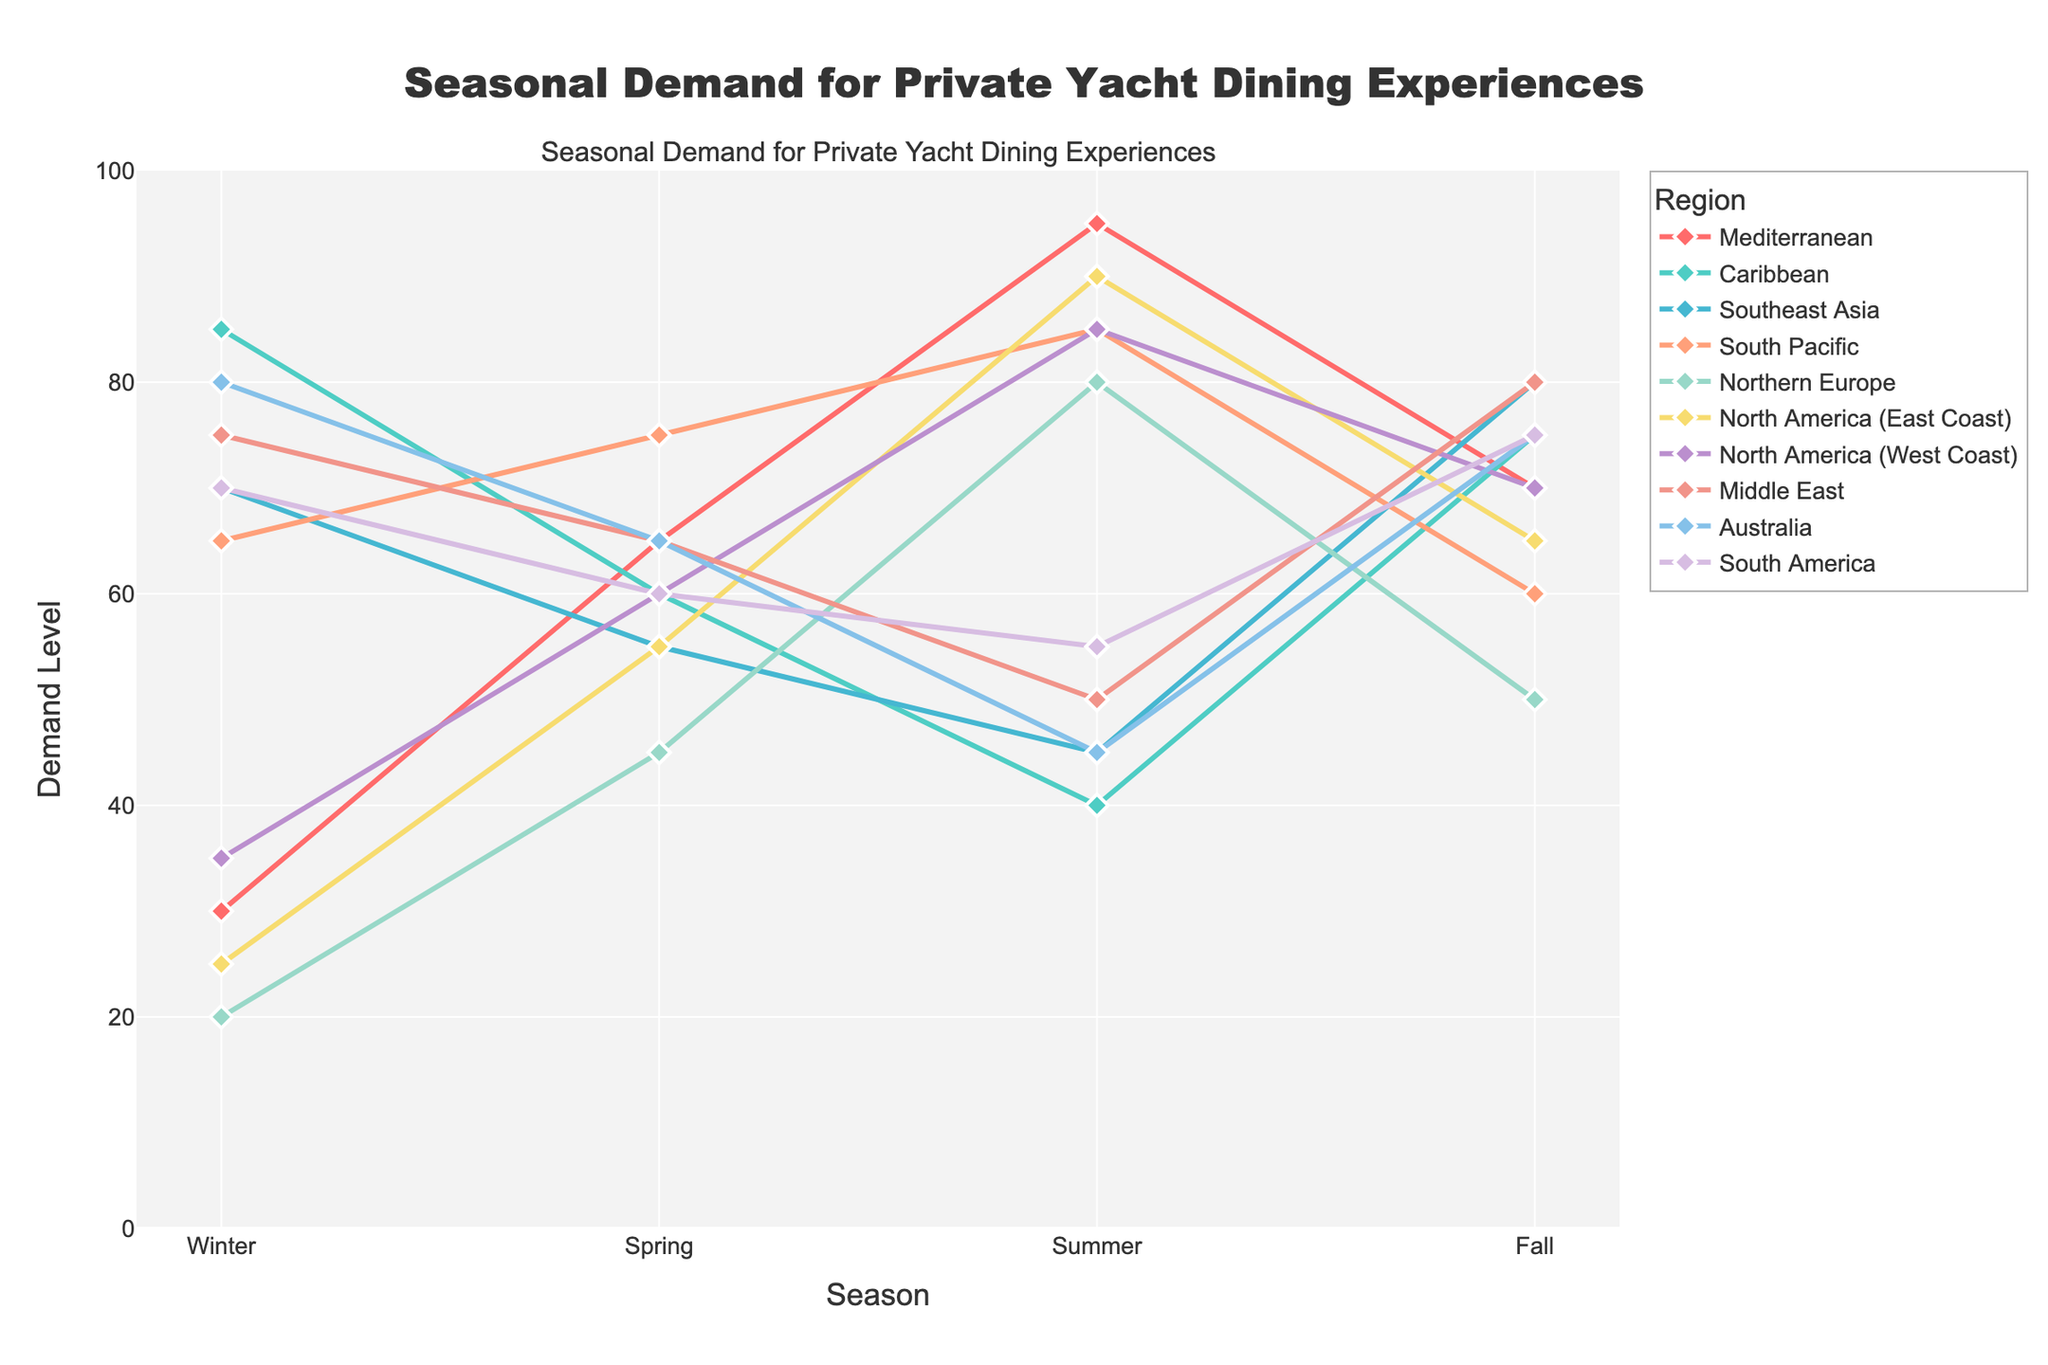What is the demand level for private yacht dining experiences in the Mediterranean during Summer? Look at the Mediterranean region line on the chart and find its corresponding value during the Summer season.
Answer: 95 During which season does the Caribbean region have the highest demand? Examine the line representing the Caribbean region and identify the peak point across the seasons.
Answer: Winter Which region has the highest demand in Fall? Observe the demand levels in Fall for all regions and identify the one with the highest value.
Answer: Middle East What is the average demand across all regions in Winter? Sum the demand levels for each region in Winter and divide by the number of regions (30 + 85 + 70 + 65 + 20 + 25 + 35 + 75 + 80 + 70) / 10.
Answer: 55.5 In which season does Southeast Asia have the lowest demand? Look at the line for Southeast Asia and find the lowest data point.
Answer: Summer Which region experiences the most significant increase in demand from Winter to Summer? Calculate the difference between Summer and Winter demand for each region and find the one with the largest increase (Mediterranean: 65, Caribbean: -45, Southeast Asia: -25, South Pacific: 20, Northern Europe: 60, North America (East Coast): 65, North America (West Coast): 50, Middle East: -25, Australia: -35, South America: -15).
Answer: Mediterranean How does the demand in Northern Europe during Fall compare to that in Spring? Compare the demand values for Northern Europe in Fall and Spring (Fall: 50, Spring: 45).
Answer: Higher in Fall What is the total demand for dining experiences in Summer across all regions? Add the demand values for all regions in Summer (95 + 40 + 45 + 85 + 80 + 90 + 85 + 50 + 45 + 55).
Answer: 670 Compare the demand for the North America (West Coast) region in Winter and Fall. Which season has higher demand? Compare the demand values for North America (West Coast) in Winter (35) and Fall (70).
Answer: Fall Which region has a higher demand in Spring, the Middle East or Northern Europe? Compare the Spring demand values for the Middle East and Northern Europe (Middle East: 65, Northern Europe: 45).
Answer: Middle East 